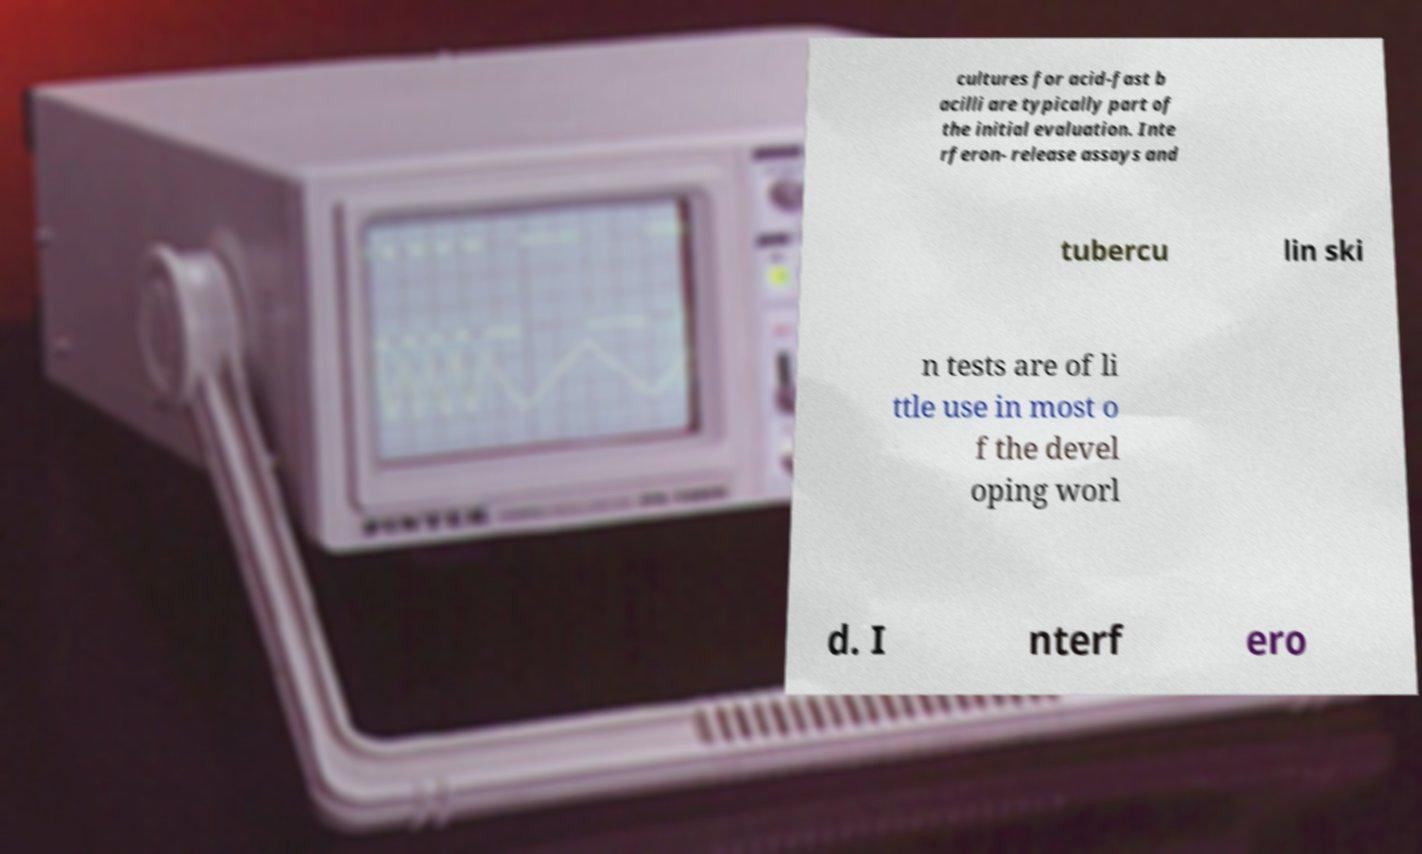Please identify and transcribe the text found in this image. cultures for acid-fast b acilli are typically part of the initial evaluation. Inte rferon- release assays and tubercu lin ski n tests are of li ttle use in most o f the devel oping worl d. I nterf ero 